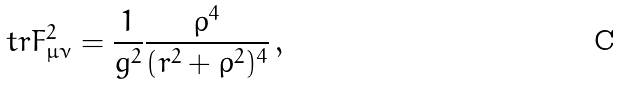<formula> <loc_0><loc_0><loc_500><loc_500>\ t r F _ { \mu \nu } ^ { 2 } = \frac { 1 } { g ^ { 2 } } \frac { \rho ^ { 4 } } { ( r ^ { 2 } + \rho ^ { 2 } ) ^ { 4 } } \, ,</formula> 